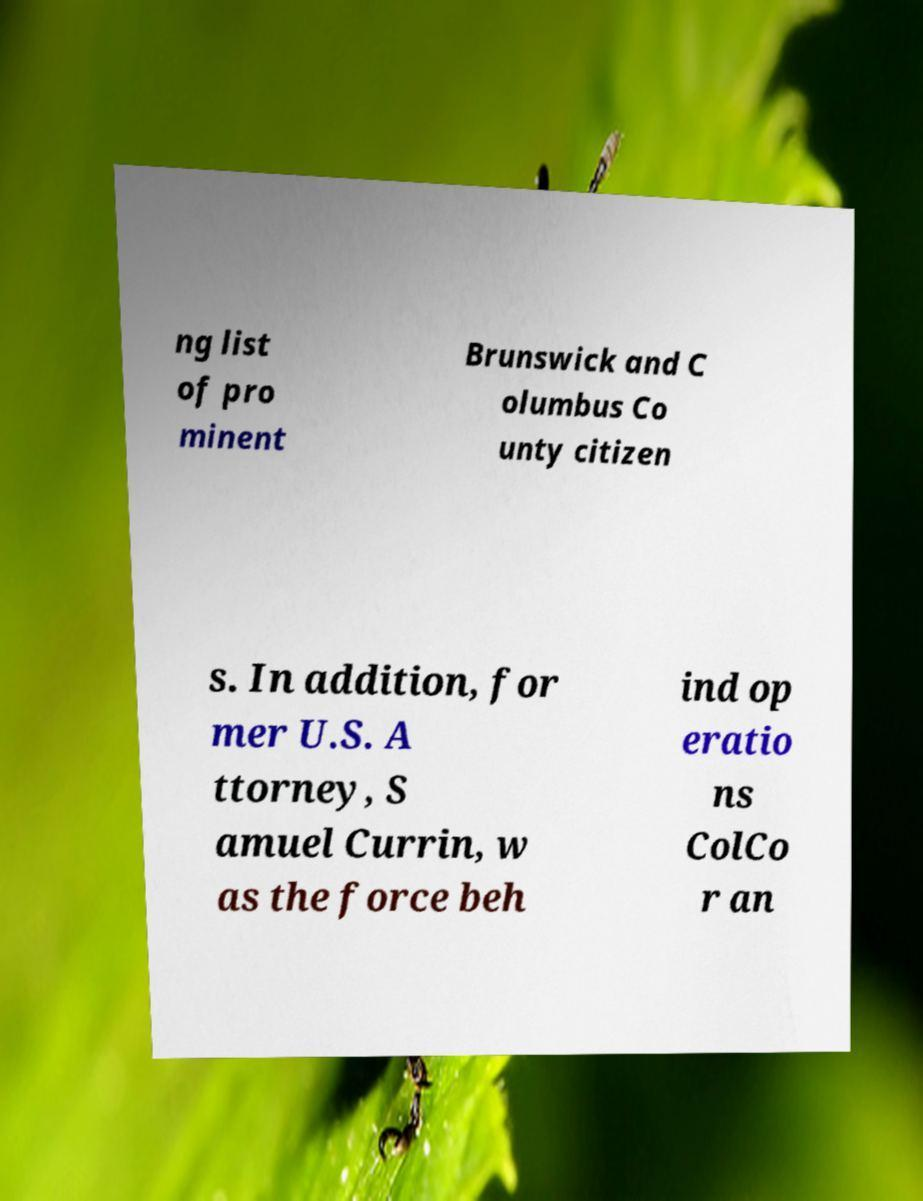Can you read and provide the text displayed in the image?This photo seems to have some interesting text. Can you extract and type it out for me? ng list of pro minent Brunswick and C olumbus Co unty citizen s. In addition, for mer U.S. A ttorney, S amuel Currin, w as the force beh ind op eratio ns ColCo r an 